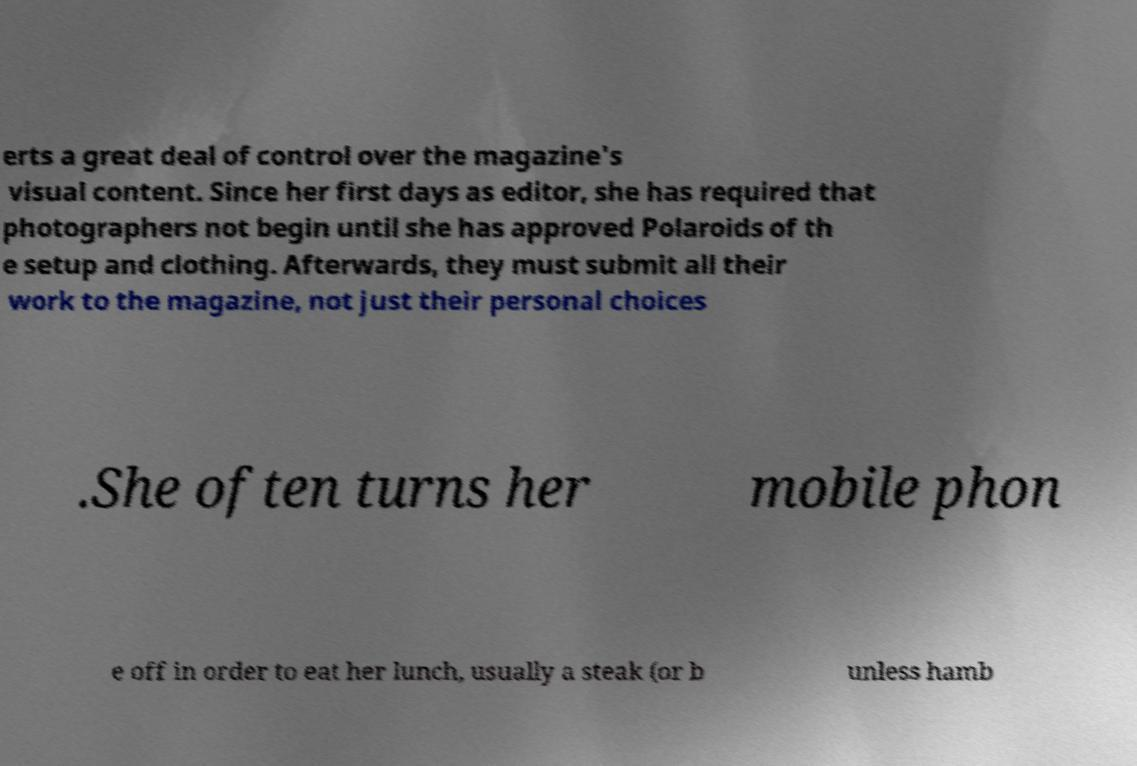Can you read and provide the text displayed in the image?This photo seems to have some interesting text. Can you extract and type it out for me? erts a great deal of control over the magazine's visual content. Since her first days as editor, she has required that photographers not begin until she has approved Polaroids of th e setup and clothing. Afterwards, they must submit all their work to the magazine, not just their personal choices .She often turns her mobile phon e off in order to eat her lunch, usually a steak (or b unless hamb 